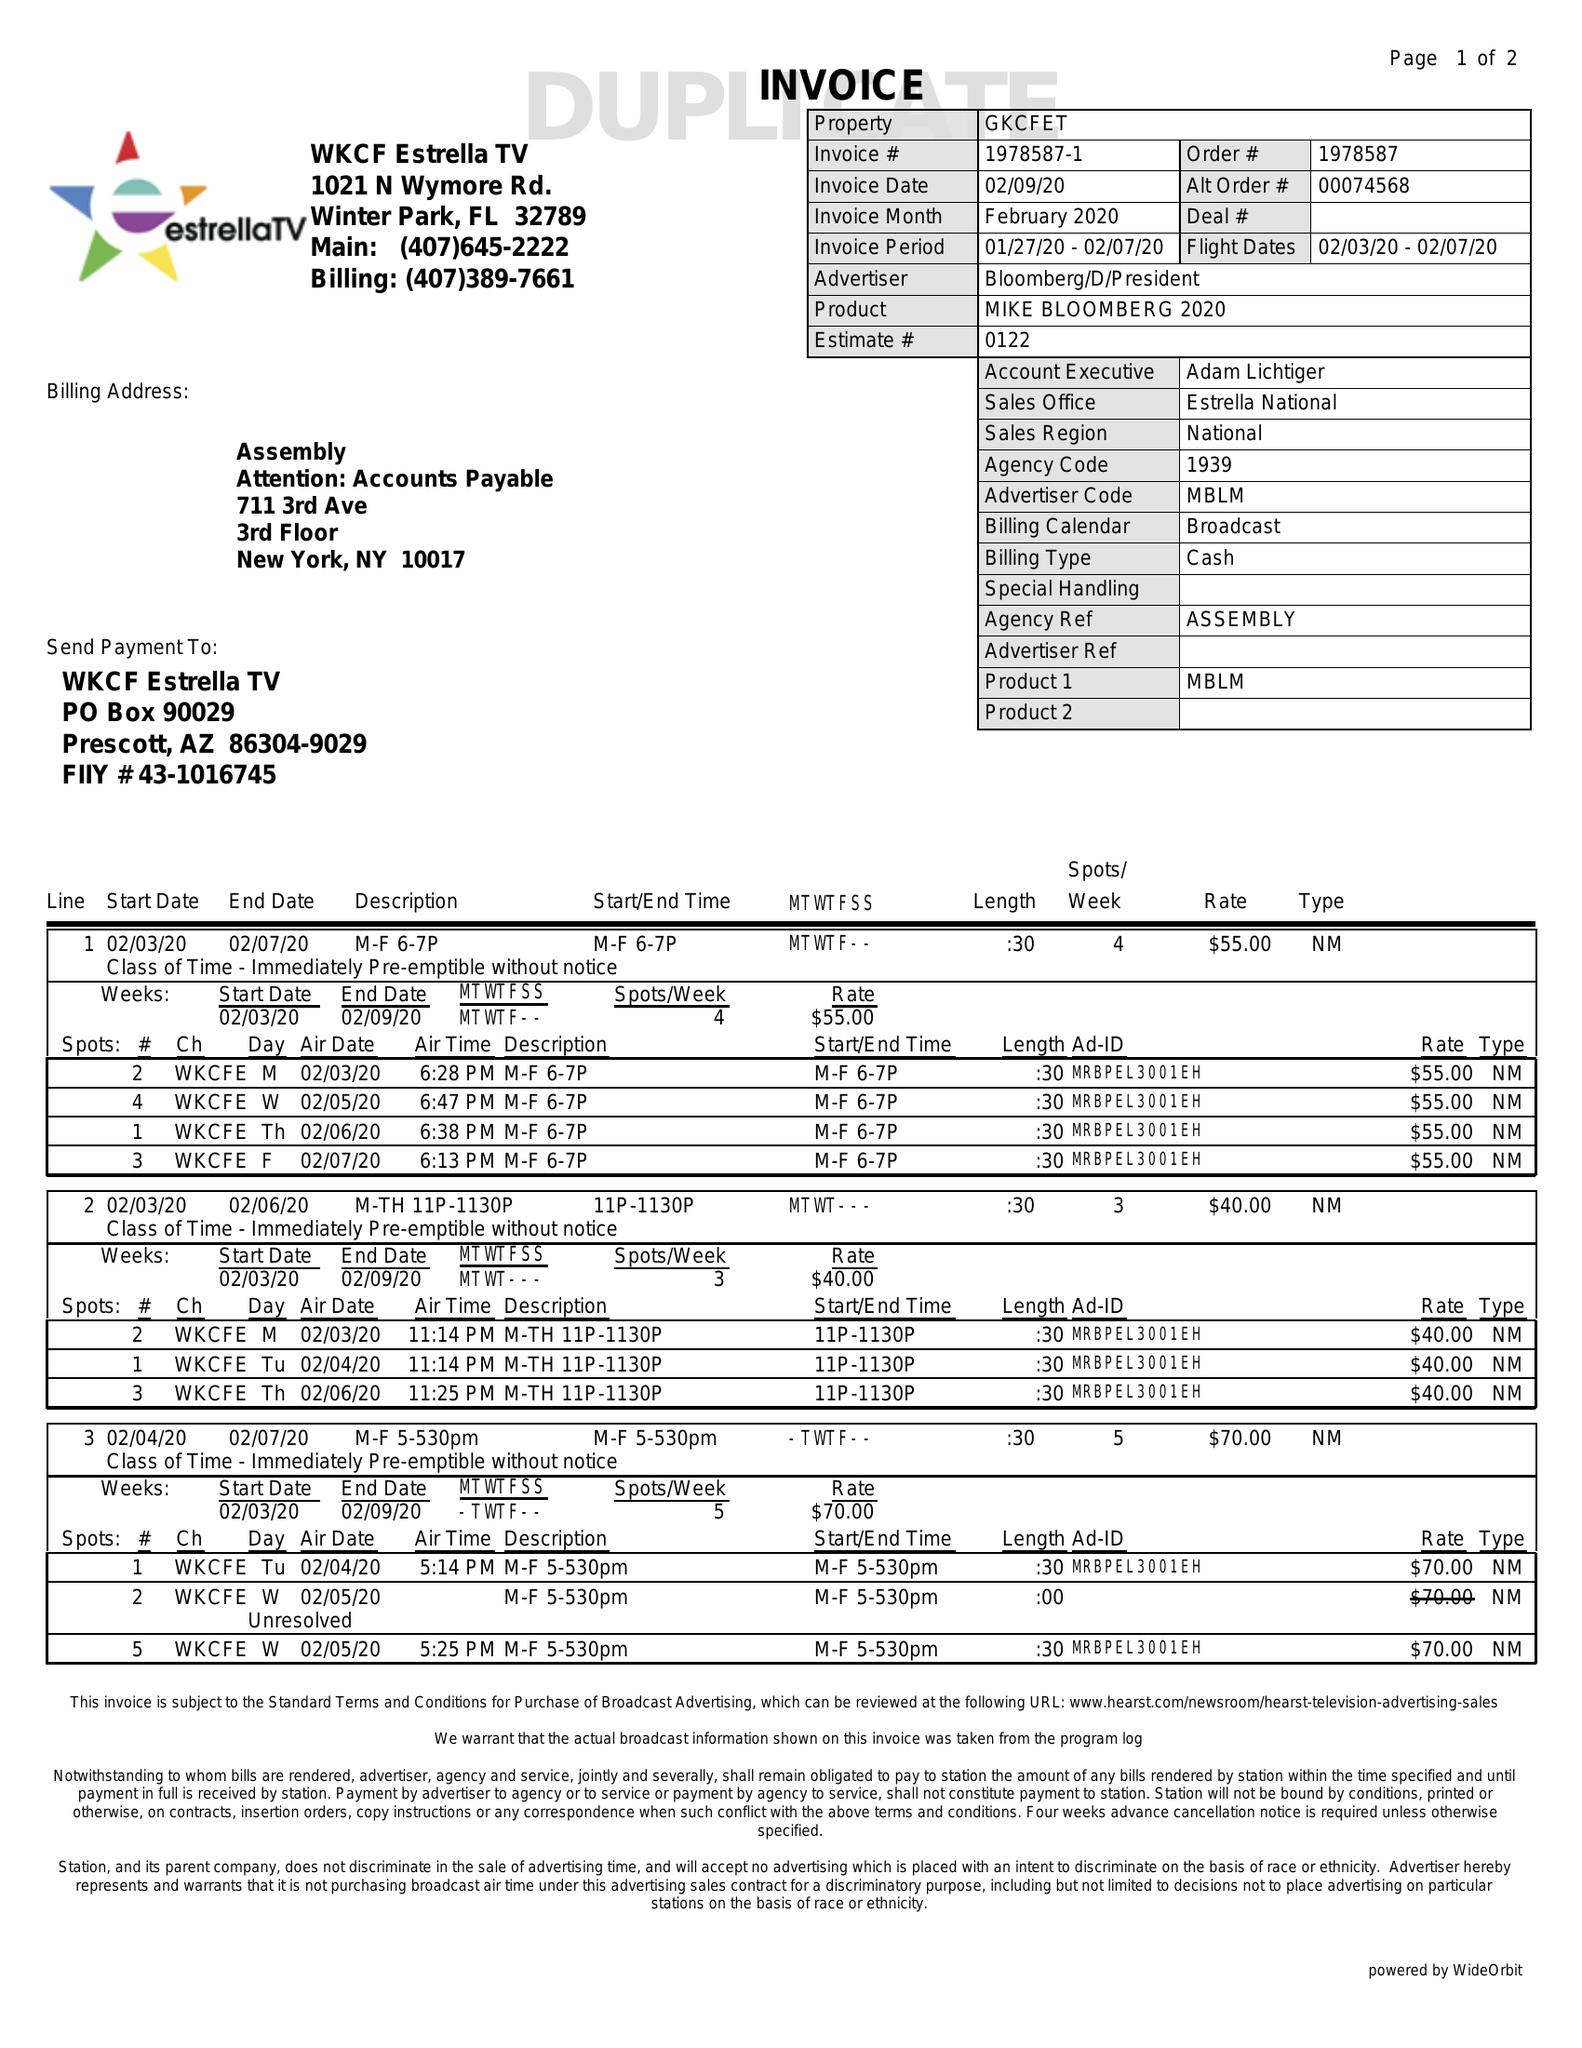What is the value for the contract_num?
Answer the question using a single word or phrase. 1978587 